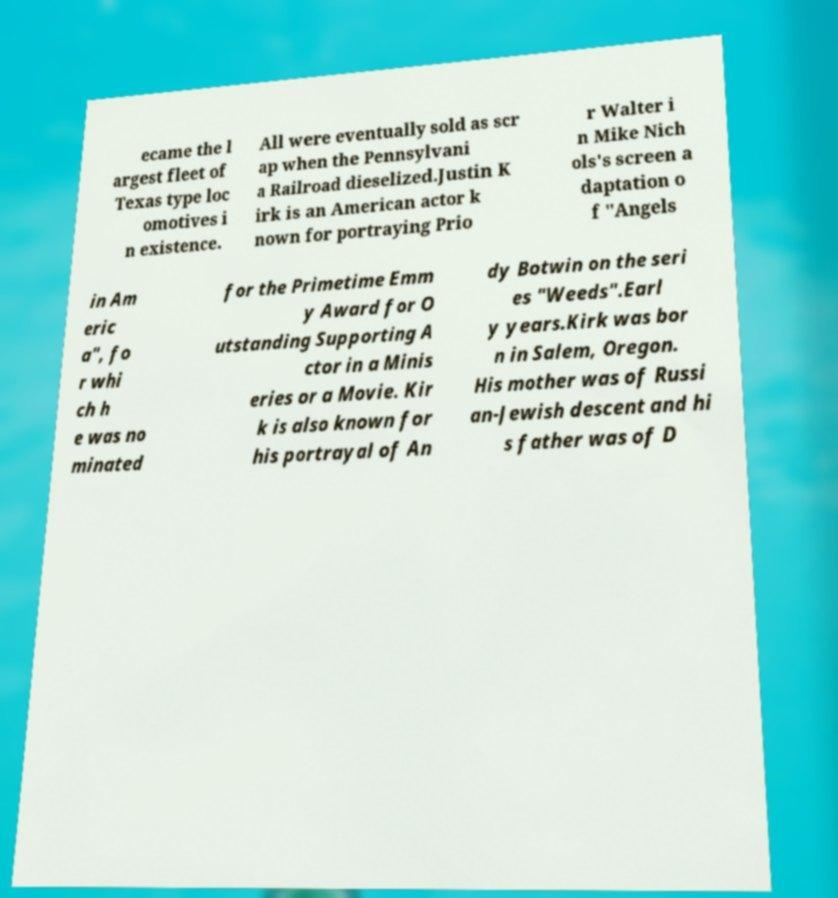There's text embedded in this image that I need extracted. Can you transcribe it verbatim? ecame the l argest fleet of Texas type loc omotives i n existence. All were eventually sold as scr ap when the Pennsylvani a Railroad dieselized.Justin K irk is an American actor k nown for portraying Prio r Walter i n Mike Nich ols's screen a daptation o f "Angels in Am eric a", fo r whi ch h e was no minated for the Primetime Emm y Award for O utstanding Supporting A ctor in a Minis eries or a Movie. Kir k is also known for his portrayal of An dy Botwin on the seri es "Weeds".Earl y years.Kirk was bor n in Salem, Oregon. His mother was of Russi an-Jewish descent and hi s father was of D 